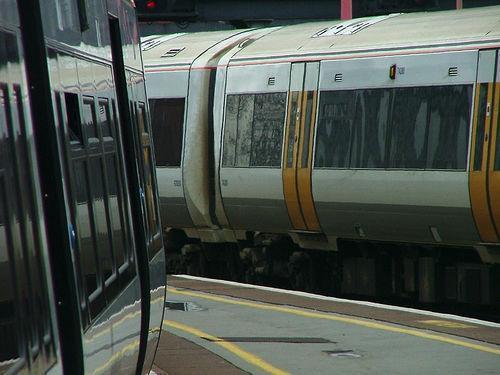How many subway trains are in the photo?
Give a very brief answer. 2. 